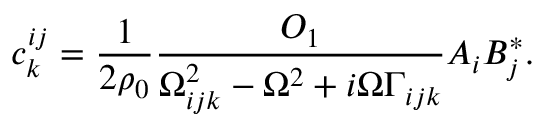<formula> <loc_0><loc_0><loc_500><loc_500>c _ { k } ^ { i j } = \frac { 1 } { 2 \rho _ { 0 } } \frac { O _ { 1 } } { \Omega _ { i j k } ^ { 2 } - \Omega ^ { 2 } + i \Omega \Gamma _ { i j k } } A _ { i } B _ { j } ^ { * } .</formula> 